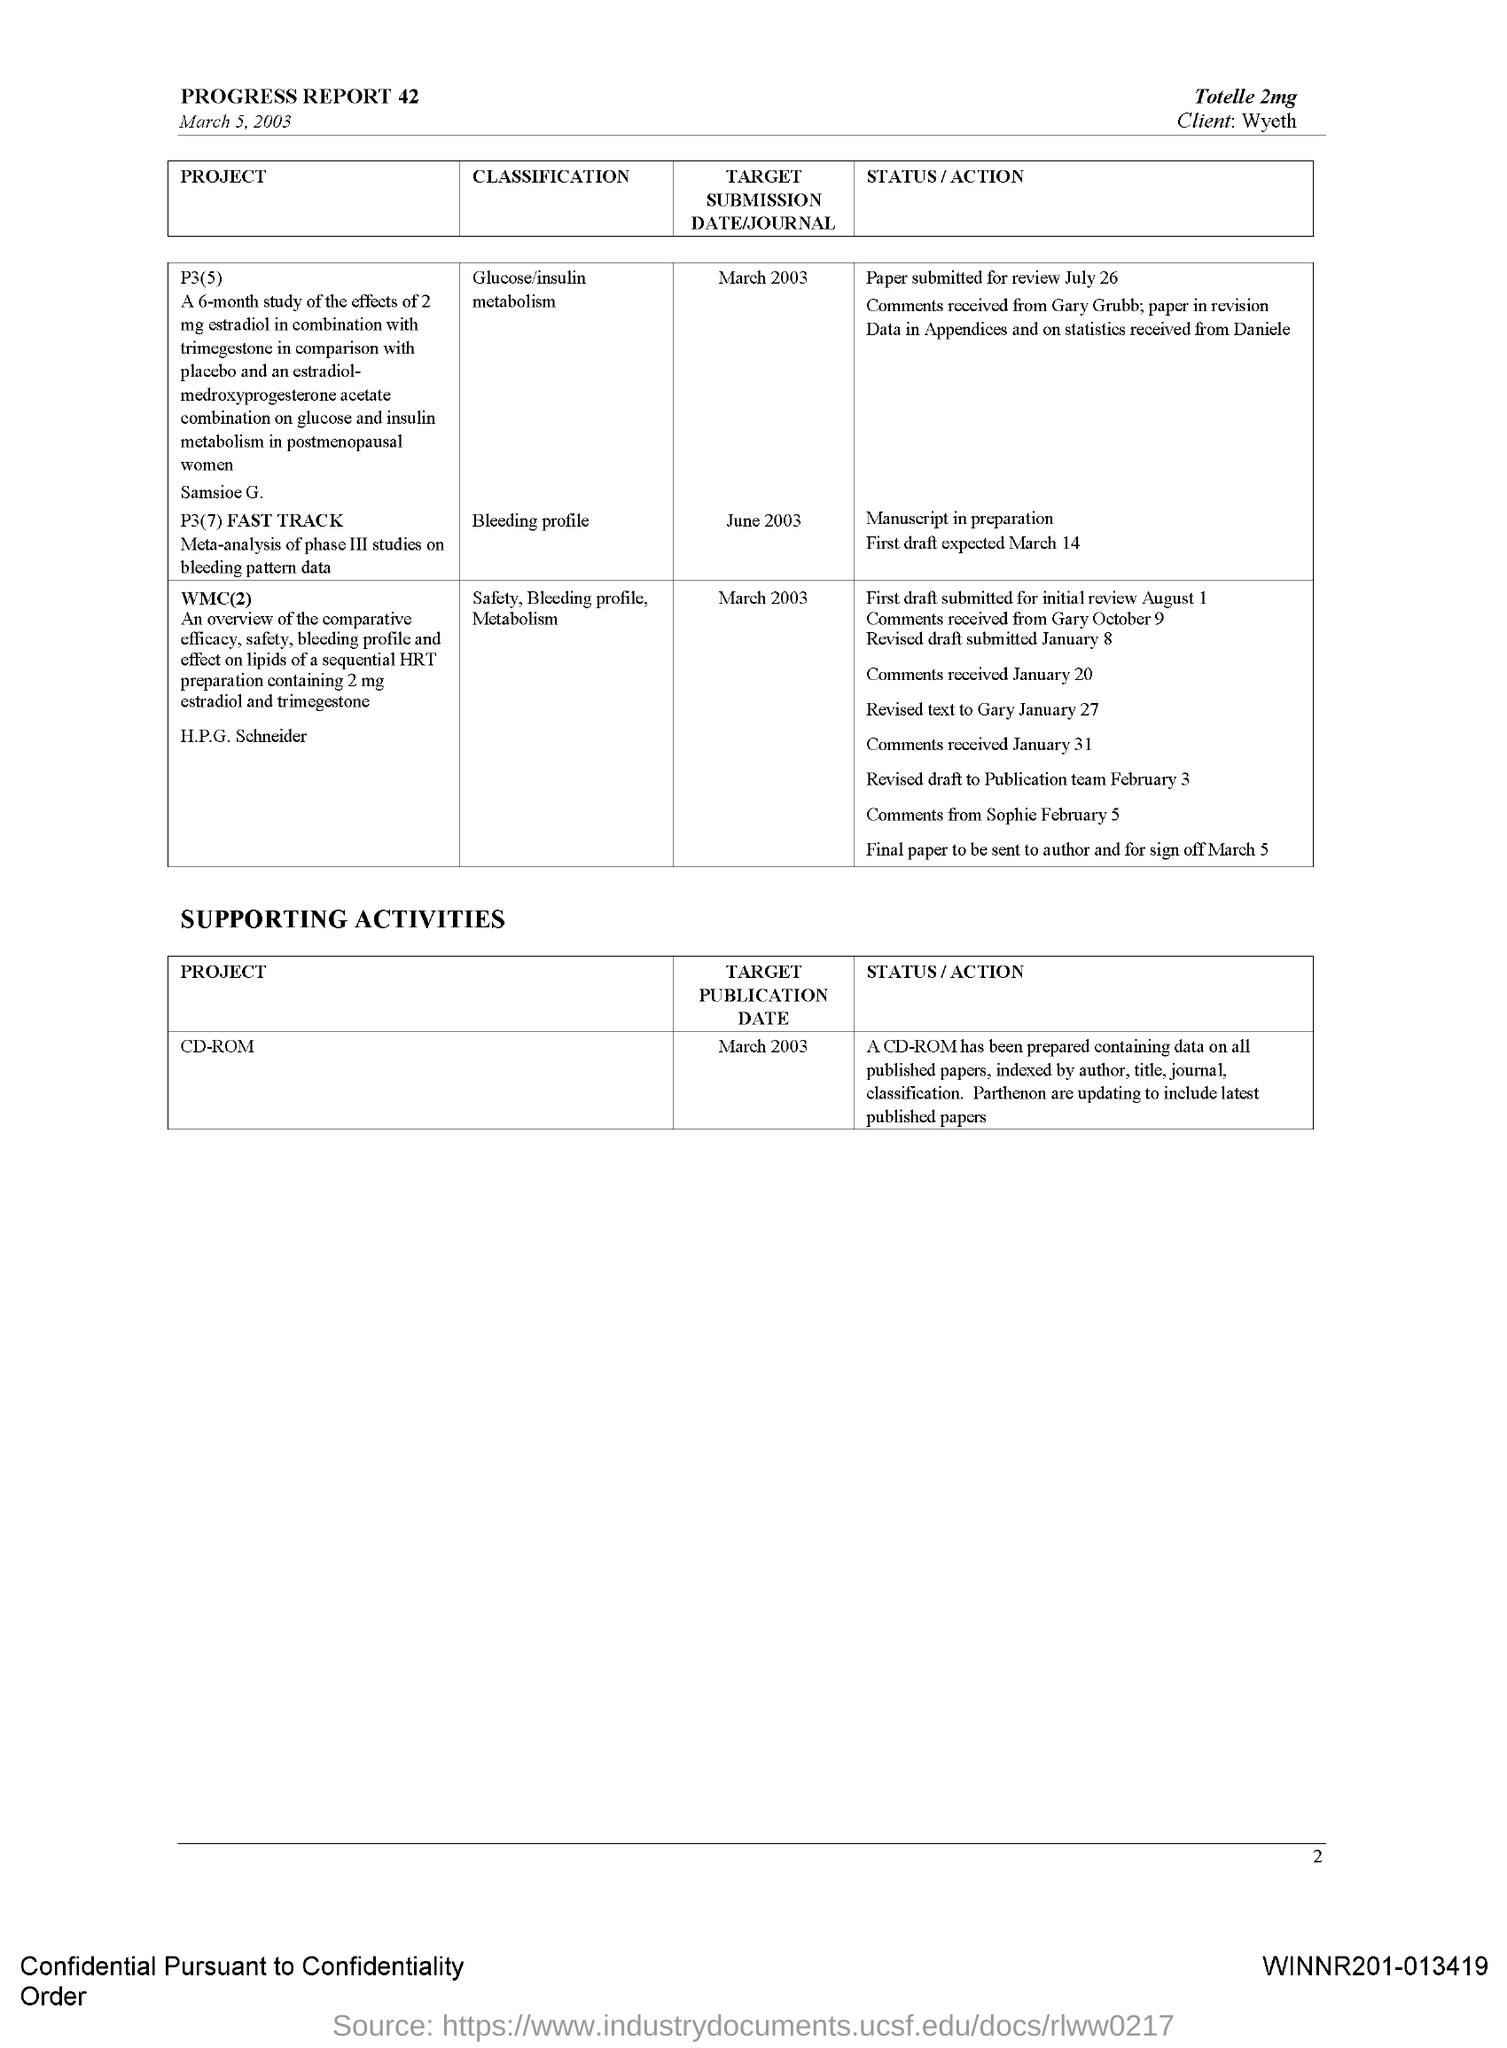Give some essential details in this illustration. The document in question bears the date of March 5, 2003. The target publication date for the Project "CD-ROM" is March 2003. The target publication date/journal for the classification "Safety, Bleeding profile, metabolism" is March 2003. The target publication date/journal for the classification of "Glucose/insulin metabolism" is March 2003. The client is Wyeth. 